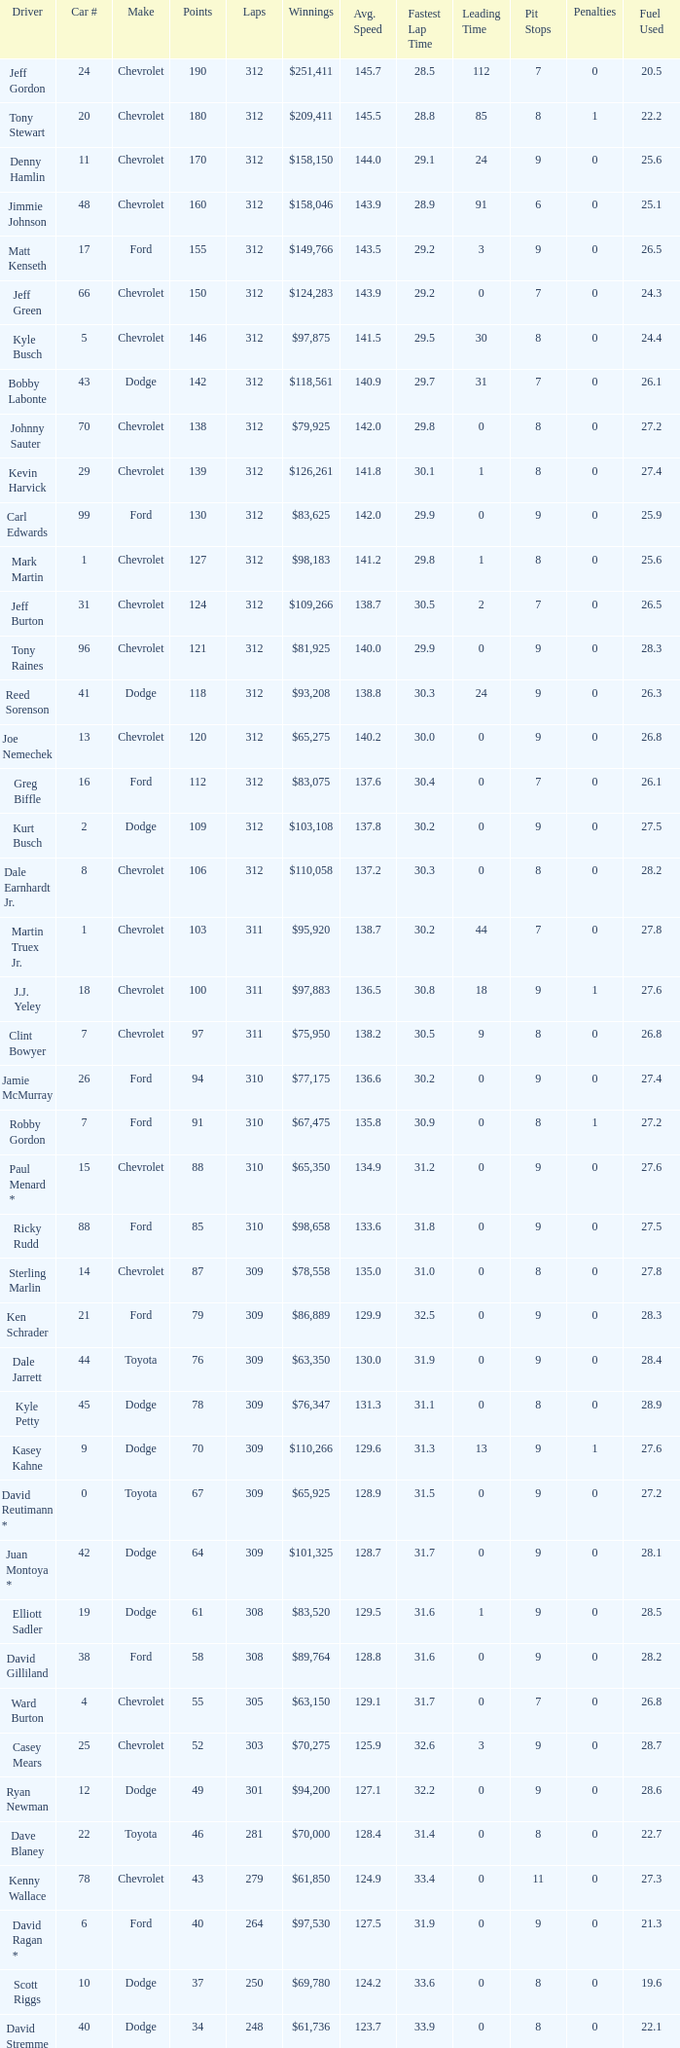What is the sum of laps that has a car number of larger than 1, is a ford, and has 155 points? 312.0. 